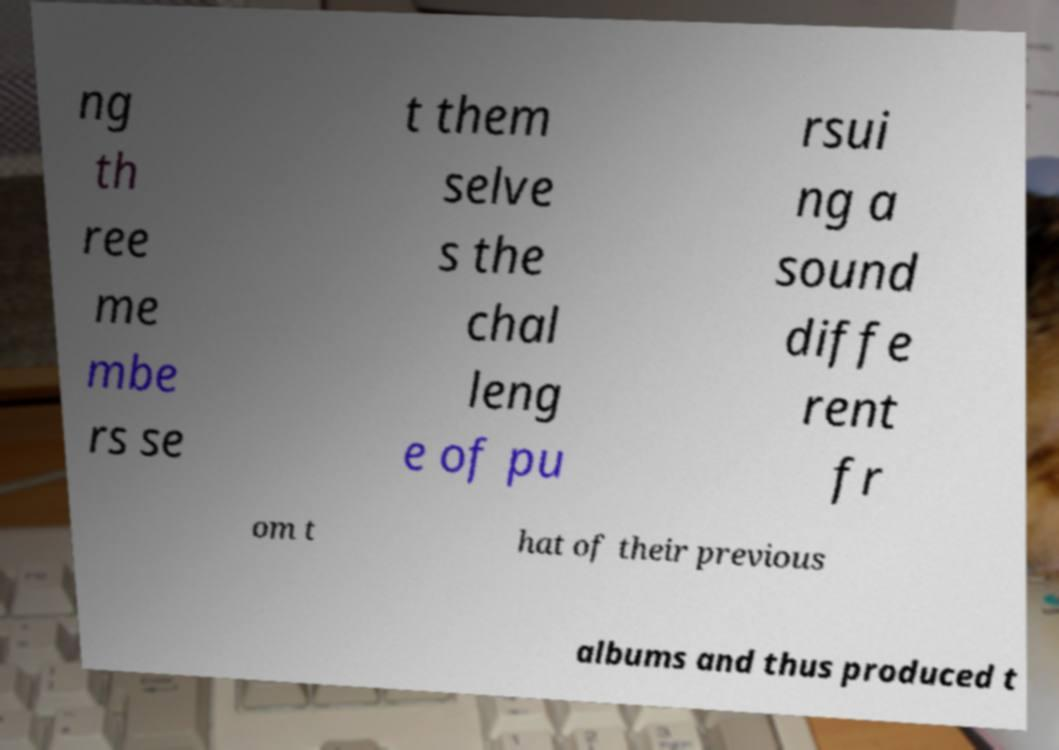Can you read and provide the text displayed in the image?This photo seems to have some interesting text. Can you extract and type it out for me? ng th ree me mbe rs se t them selve s the chal leng e of pu rsui ng a sound diffe rent fr om t hat of their previous albums and thus produced t 